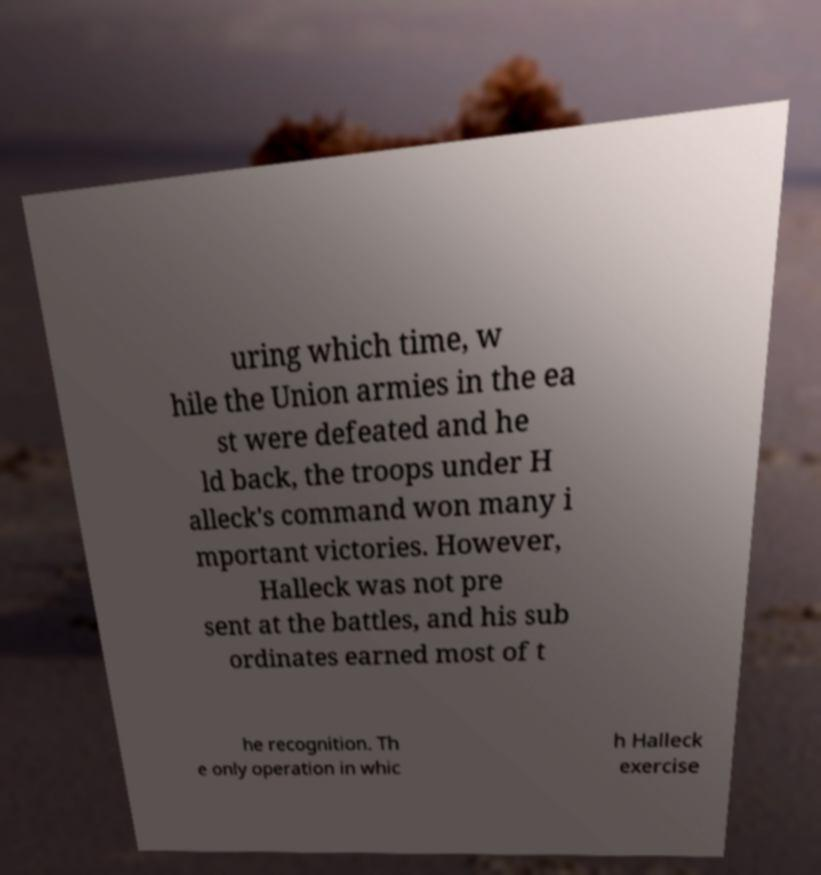Could you assist in decoding the text presented in this image and type it out clearly? uring which time, w hile the Union armies in the ea st were defeated and he ld back, the troops under H alleck's command won many i mportant victories. However, Halleck was not pre sent at the battles, and his sub ordinates earned most of t he recognition. Th e only operation in whic h Halleck exercise 